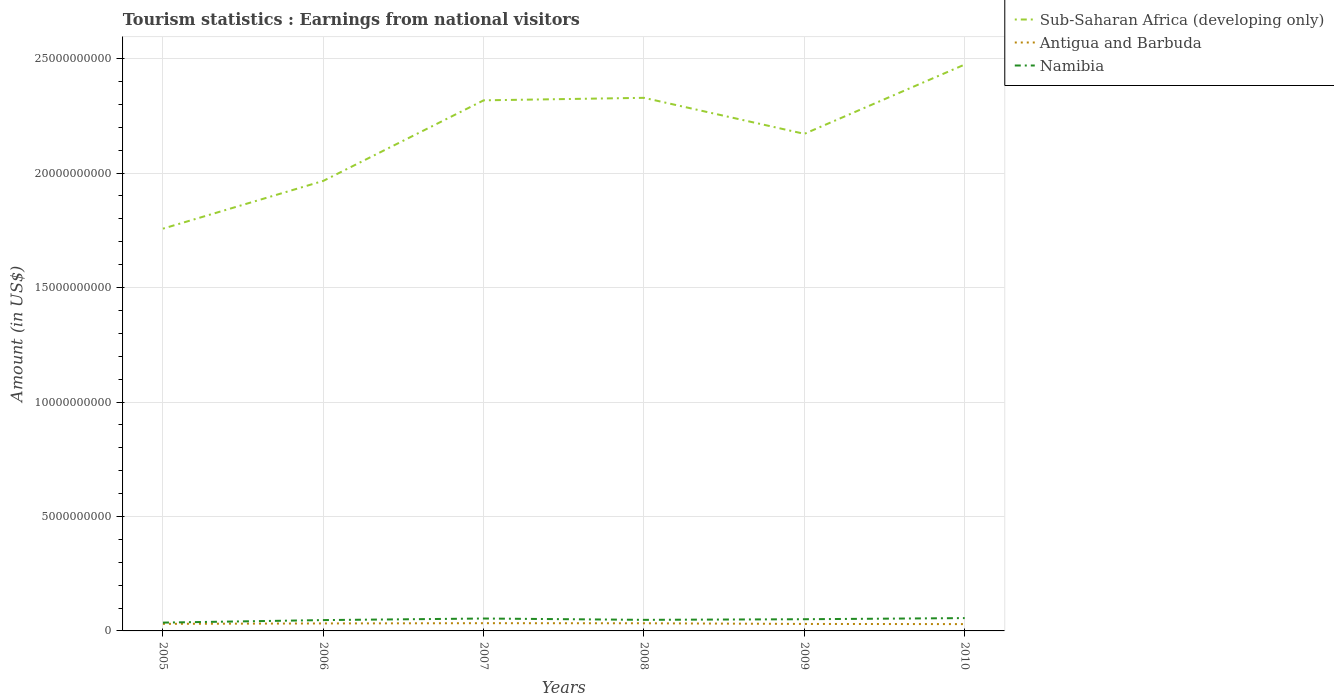Is the number of lines equal to the number of legend labels?
Your response must be concise. Yes. Across all years, what is the maximum earnings from national visitors in Antigua and Barbuda?
Make the answer very short. 2.98e+08. What is the total earnings from national visitors in Namibia in the graph?
Make the answer very short. -1.21e+08. What is the difference between the highest and the second highest earnings from national visitors in Namibia?
Offer a very short reply. 1.97e+08. What is the difference between the highest and the lowest earnings from national visitors in Namibia?
Provide a short and direct response. 3. Is the earnings from national visitors in Antigua and Barbuda strictly greater than the earnings from national visitors in Sub-Saharan Africa (developing only) over the years?
Keep it short and to the point. Yes. How many lines are there?
Your response must be concise. 3. Are the values on the major ticks of Y-axis written in scientific E-notation?
Your answer should be very brief. No. How many legend labels are there?
Make the answer very short. 3. How are the legend labels stacked?
Your answer should be very brief. Vertical. What is the title of the graph?
Provide a succinct answer. Tourism statistics : Earnings from national visitors. What is the Amount (in US$) of Sub-Saharan Africa (developing only) in 2005?
Offer a terse response. 1.76e+1. What is the Amount (in US$) of Antigua and Barbuda in 2005?
Provide a succinct answer. 3.09e+08. What is the Amount (in US$) of Namibia in 2005?
Your response must be concise. 3.63e+08. What is the Amount (in US$) of Sub-Saharan Africa (developing only) in 2006?
Your response must be concise. 1.97e+1. What is the Amount (in US$) of Antigua and Barbuda in 2006?
Your response must be concise. 3.27e+08. What is the Amount (in US$) of Namibia in 2006?
Give a very brief answer. 4.73e+08. What is the Amount (in US$) of Sub-Saharan Africa (developing only) in 2007?
Give a very brief answer. 2.32e+1. What is the Amount (in US$) in Antigua and Barbuda in 2007?
Provide a short and direct response. 3.38e+08. What is the Amount (in US$) of Namibia in 2007?
Make the answer very short. 5.42e+08. What is the Amount (in US$) in Sub-Saharan Africa (developing only) in 2008?
Provide a short and direct response. 2.33e+1. What is the Amount (in US$) of Antigua and Barbuda in 2008?
Provide a succinct answer. 3.34e+08. What is the Amount (in US$) in Namibia in 2008?
Your answer should be compact. 4.84e+08. What is the Amount (in US$) in Sub-Saharan Africa (developing only) in 2009?
Keep it short and to the point. 2.17e+1. What is the Amount (in US$) in Antigua and Barbuda in 2009?
Your answer should be compact. 3.05e+08. What is the Amount (in US$) in Namibia in 2009?
Keep it short and to the point. 5.11e+08. What is the Amount (in US$) of Sub-Saharan Africa (developing only) in 2010?
Offer a terse response. 2.47e+1. What is the Amount (in US$) of Antigua and Barbuda in 2010?
Keep it short and to the point. 2.98e+08. What is the Amount (in US$) in Namibia in 2010?
Offer a very short reply. 5.60e+08. Across all years, what is the maximum Amount (in US$) in Sub-Saharan Africa (developing only)?
Keep it short and to the point. 2.47e+1. Across all years, what is the maximum Amount (in US$) in Antigua and Barbuda?
Your answer should be compact. 3.38e+08. Across all years, what is the maximum Amount (in US$) of Namibia?
Your answer should be very brief. 5.60e+08. Across all years, what is the minimum Amount (in US$) in Sub-Saharan Africa (developing only)?
Your answer should be compact. 1.76e+1. Across all years, what is the minimum Amount (in US$) in Antigua and Barbuda?
Offer a very short reply. 2.98e+08. Across all years, what is the minimum Amount (in US$) in Namibia?
Your answer should be very brief. 3.63e+08. What is the total Amount (in US$) in Sub-Saharan Africa (developing only) in the graph?
Provide a short and direct response. 1.30e+11. What is the total Amount (in US$) of Antigua and Barbuda in the graph?
Make the answer very short. 1.91e+09. What is the total Amount (in US$) in Namibia in the graph?
Give a very brief answer. 2.93e+09. What is the difference between the Amount (in US$) of Sub-Saharan Africa (developing only) in 2005 and that in 2006?
Give a very brief answer. -2.09e+09. What is the difference between the Amount (in US$) in Antigua and Barbuda in 2005 and that in 2006?
Give a very brief answer. -1.80e+07. What is the difference between the Amount (in US$) of Namibia in 2005 and that in 2006?
Keep it short and to the point. -1.10e+08. What is the difference between the Amount (in US$) in Sub-Saharan Africa (developing only) in 2005 and that in 2007?
Make the answer very short. -5.61e+09. What is the difference between the Amount (in US$) of Antigua and Barbuda in 2005 and that in 2007?
Offer a very short reply. -2.90e+07. What is the difference between the Amount (in US$) in Namibia in 2005 and that in 2007?
Keep it short and to the point. -1.79e+08. What is the difference between the Amount (in US$) in Sub-Saharan Africa (developing only) in 2005 and that in 2008?
Offer a terse response. -5.71e+09. What is the difference between the Amount (in US$) in Antigua and Barbuda in 2005 and that in 2008?
Offer a terse response. -2.50e+07. What is the difference between the Amount (in US$) of Namibia in 2005 and that in 2008?
Your response must be concise. -1.21e+08. What is the difference between the Amount (in US$) of Sub-Saharan Africa (developing only) in 2005 and that in 2009?
Make the answer very short. -4.14e+09. What is the difference between the Amount (in US$) in Namibia in 2005 and that in 2009?
Make the answer very short. -1.48e+08. What is the difference between the Amount (in US$) in Sub-Saharan Africa (developing only) in 2005 and that in 2010?
Your answer should be very brief. -7.17e+09. What is the difference between the Amount (in US$) of Antigua and Barbuda in 2005 and that in 2010?
Ensure brevity in your answer.  1.10e+07. What is the difference between the Amount (in US$) in Namibia in 2005 and that in 2010?
Your answer should be very brief. -1.97e+08. What is the difference between the Amount (in US$) in Sub-Saharan Africa (developing only) in 2006 and that in 2007?
Offer a very short reply. -3.52e+09. What is the difference between the Amount (in US$) of Antigua and Barbuda in 2006 and that in 2007?
Your answer should be compact. -1.10e+07. What is the difference between the Amount (in US$) of Namibia in 2006 and that in 2007?
Make the answer very short. -6.90e+07. What is the difference between the Amount (in US$) of Sub-Saharan Africa (developing only) in 2006 and that in 2008?
Provide a succinct answer. -3.63e+09. What is the difference between the Amount (in US$) in Antigua and Barbuda in 2006 and that in 2008?
Offer a terse response. -7.00e+06. What is the difference between the Amount (in US$) in Namibia in 2006 and that in 2008?
Offer a very short reply. -1.10e+07. What is the difference between the Amount (in US$) of Sub-Saharan Africa (developing only) in 2006 and that in 2009?
Make the answer very short. -2.05e+09. What is the difference between the Amount (in US$) in Antigua and Barbuda in 2006 and that in 2009?
Keep it short and to the point. 2.20e+07. What is the difference between the Amount (in US$) of Namibia in 2006 and that in 2009?
Offer a terse response. -3.80e+07. What is the difference between the Amount (in US$) in Sub-Saharan Africa (developing only) in 2006 and that in 2010?
Your answer should be compact. -5.08e+09. What is the difference between the Amount (in US$) of Antigua and Barbuda in 2006 and that in 2010?
Give a very brief answer. 2.90e+07. What is the difference between the Amount (in US$) of Namibia in 2006 and that in 2010?
Provide a short and direct response. -8.70e+07. What is the difference between the Amount (in US$) of Sub-Saharan Africa (developing only) in 2007 and that in 2008?
Your answer should be very brief. -1.09e+08. What is the difference between the Amount (in US$) of Namibia in 2007 and that in 2008?
Provide a short and direct response. 5.80e+07. What is the difference between the Amount (in US$) in Sub-Saharan Africa (developing only) in 2007 and that in 2009?
Offer a very short reply. 1.46e+09. What is the difference between the Amount (in US$) of Antigua and Barbuda in 2007 and that in 2009?
Give a very brief answer. 3.30e+07. What is the difference between the Amount (in US$) in Namibia in 2007 and that in 2009?
Offer a terse response. 3.10e+07. What is the difference between the Amount (in US$) of Sub-Saharan Africa (developing only) in 2007 and that in 2010?
Your answer should be compact. -1.56e+09. What is the difference between the Amount (in US$) of Antigua and Barbuda in 2007 and that in 2010?
Keep it short and to the point. 4.00e+07. What is the difference between the Amount (in US$) in Namibia in 2007 and that in 2010?
Give a very brief answer. -1.80e+07. What is the difference between the Amount (in US$) in Sub-Saharan Africa (developing only) in 2008 and that in 2009?
Ensure brevity in your answer.  1.57e+09. What is the difference between the Amount (in US$) of Antigua and Barbuda in 2008 and that in 2009?
Offer a very short reply. 2.90e+07. What is the difference between the Amount (in US$) in Namibia in 2008 and that in 2009?
Offer a terse response. -2.70e+07. What is the difference between the Amount (in US$) of Sub-Saharan Africa (developing only) in 2008 and that in 2010?
Provide a short and direct response. -1.45e+09. What is the difference between the Amount (in US$) of Antigua and Barbuda in 2008 and that in 2010?
Offer a terse response. 3.60e+07. What is the difference between the Amount (in US$) in Namibia in 2008 and that in 2010?
Your answer should be very brief. -7.60e+07. What is the difference between the Amount (in US$) in Sub-Saharan Africa (developing only) in 2009 and that in 2010?
Offer a terse response. -3.03e+09. What is the difference between the Amount (in US$) in Namibia in 2009 and that in 2010?
Ensure brevity in your answer.  -4.90e+07. What is the difference between the Amount (in US$) in Sub-Saharan Africa (developing only) in 2005 and the Amount (in US$) in Antigua and Barbuda in 2006?
Make the answer very short. 1.72e+1. What is the difference between the Amount (in US$) of Sub-Saharan Africa (developing only) in 2005 and the Amount (in US$) of Namibia in 2006?
Keep it short and to the point. 1.71e+1. What is the difference between the Amount (in US$) of Antigua and Barbuda in 2005 and the Amount (in US$) of Namibia in 2006?
Your answer should be compact. -1.64e+08. What is the difference between the Amount (in US$) of Sub-Saharan Africa (developing only) in 2005 and the Amount (in US$) of Antigua and Barbuda in 2007?
Your response must be concise. 1.72e+1. What is the difference between the Amount (in US$) of Sub-Saharan Africa (developing only) in 2005 and the Amount (in US$) of Namibia in 2007?
Offer a very short reply. 1.70e+1. What is the difference between the Amount (in US$) in Antigua and Barbuda in 2005 and the Amount (in US$) in Namibia in 2007?
Provide a succinct answer. -2.33e+08. What is the difference between the Amount (in US$) of Sub-Saharan Africa (developing only) in 2005 and the Amount (in US$) of Antigua and Barbuda in 2008?
Ensure brevity in your answer.  1.72e+1. What is the difference between the Amount (in US$) in Sub-Saharan Africa (developing only) in 2005 and the Amount (in US$) in Namibia in 2008?
Your answer should be compact. 1.71e+1. What is the difference between the Amount (in US$) in Antigua and Barbuda in 2005 and the Amount (in US$) in Namibia in 2008?
Ensure brevity in your answer.  -1.75e+08. What is the difference between the Amount (in US$) in Sub-Saharan Africa (developing only) in 2005 and the Amount (in US$) in Antigua and Barbuda in 2009?
Your answer should be very brief. 1.73e+1. What is the difference between the Amount (in US$) in Sub-Saharan Africa (developing only) in 2005 and the Amount (in US$) in Namibia in 2009?
Your answer should be very brief. 1.71e+1. What is the difference between the Amount (in US$) of Antigua and Barbuda in 2005 and the Amount (in US$) of Namibia in 2009?
Provide a short and direct response. -2.02e+08. What is the difference between the Amount (in US$) in Sub-Saharan Africa (developing only) in 2005 and the Amount (in US$) in Antigua and Barbuda in 2010?
Provide a short and direct response. 1.73e+1. What is the difference between the Amount (in US$) in Sub-Saharan Africa (developing only) in 2005 and the Amount (in US$) in Namibia in 2010?
Offer a terse response. 1.70e+1. What is the difference between the Amount (in US$) of Antigua and Barbuda in 2005 and the Amount (in US$) of Namibia in 2010?
Give a very brief answer. -2.51e+08. What is the difference between the Amount (in US$) in Sub-Saharan Africa (developing only) in 2006 and the Amount (in US$) in Antigua and Barbuda in 2007?
Ensure brevity in your answer.  1.93e+1. What is the difference between the Amount (in US$) in Sub-Saharan Africa (developing only) in 2006 and the Amount (in US$) in Namibia in 2007?
Your answer should be very brief. 1.91e+1. What is the difference between the Amount (in US$) in Antigua and Barbuda in 2006 and the Amount (in US$) in Namibia in 2007?
Make the answer very short. -2.15e+08. What is the difference between the Amount (in US$) of Sub-Saharan Africa (developing only) in 2006 and the Amount (in US$) of Antigua and Barbuda in 2008?
Keep it short and to the point. 1.93e+1. What is the difference between the Amount (in US$) of Sub-Saharan Africa (developing only) in 2006 and the Amount (in US$) of Namibia in 2008?
Offer a terse response. 1.92e+1. What is the difference between the Amount (in US$) of Antigua and Barbuda in 2006 and the Amount (in US$) of Namibia in 2008?
Give a very brief answer. -1.57e+08. What is the difference between the Amount (in US$) of Sub-Saharan Africa (developing only) in 2006 and the Amount (in US$) of Antigua and Barbuda in 2009?
Provide a short and direct response. 1.94e+1. What is the difference between the Amount (in US$) of Sub-Saharan Africa (developing only) in 2006 and the Amount (in US$) of Namibia in 2009?
Keep it short and to the point. 1.91e+1. What is the difference between the Amount (in US$) of Antigua and Barbuda in 2006 and the Amount (in US$) of Namibia in 2009?
Give a very brief answer. -1.84e+08. What is the difference between the Amount (in US$) of Sub-Saharan Africa (developing only) in 2006 and the Amount (in US$) of Antigua and Barbuda in 2010?
Your response must be concise. 1.94e+1. What is the difference between the Amount (in US$) in Sub-Saharan Africa (developing only) in 2006 and the Amount (in US$) in Namibia in 2010?
Ensure brevity in your answer.  1.91e+1. What is the difference between the Amount (in US$) of Antigua and Barbuda in 2006 and the Amount (in US$) of Namibia in 2010?
Provide a succinct answer. -2.33e+08. What is the difference between the Amount (in US$) in Sub-Saharan Africa (developing only) in 2007 and the Amount (in US$) in Antigua and Barbuda in 2008?
Ensure brevity in your answer.  2.28e+1. What is the difference between the Amount (in US$) in Sub-Saharan Africa (developing only) in 2007 and the Amount (in US$) in Namibia in 2008?
Give a very brief answer. 2.27e+1. What is the difference between the Amount (in US$) of Antigua and Barbuda in 2007 and the Amount (in US$) of Namibia in 2008?
Provide a succinct answer. -1.46e+08. What is the difference between the Amount (in US$) of Sub-Saharan Africa (developing only) in 2007 and the Amount (in US$) of Antigua and Barbuda in 2009?
Offer a terse response. 2.29e+1. What is the difference between the Amount (in US$) of Sub-Saharan Africa (developing only) in 2007 and the Amount (in US$) of Namibia in 2009?
Ensure brevity in your answer.  2.27e+1. What is the difference between the Amount (in US$) in Antigua and Barbuda in 2007 and the Amount (in US$) in Namibia in 2009?
Your response must be concise. -1.73e+08. What is the difference between the Amount (in US$) of Sub-Saharan Africa (developing only) in 2007 and the Amount (in US$) of Antigua and Barbuda in 2010?
Provide a short and direct response. 2.29e+1. What is the difference between the Amount (in US$) in Sub-Saharan Africa (developing only) in 2007 and the Amount (in US$) in Namibia in 2010?
Give a very brief answer. 2.26e+1. What is the difference between the Amount (in US$) of Antigua and Barbuda in 2007 and the Amount (in US$) of Namibia in 2010?
Keep it short and to the point. -2.22e+08. What is the difference between the Amount (in US$) in Sub-Saharan Africa (developing only) in 2008 and the Amount (in US$) in Antigua and Barbuda in 2009?
Offer a very short reply. 2.30e+1. What is the difference between the Amount (in US$) of Sub-Saharan Africa (developing only) in 2008 and the Amount (in US$) of Namibia in 2009?
Keep it short and to the point. 2.28e+1. What is the difference between the Amount (in US$) in Antigua and Barbuda in 2008 and the Amount (in US$) in Namibia in 2009?
Keep it short and to the point. -1.77e+08. What is the difference between the Amount (in US$) of Sub-Saharan Africa (developing only) in 2008 and the Amount (in US$) of Antigua and Barbuda in 2010?
Your answer should be very brief. 2.30e+1. What is the difference between the Amount (in US$) in Sub-Saharan Africa (developing only) in 2008 and the Amount (in US$) in Namibia in 2010?
Your answer should be compact. 2.27e+1. What is the difference between the Amount (in US$) in Antigua and Barbuda in 2008 and the Amount (in US$) in Namibia in 2010?
Offer a very short reply. -2.26e+08. What is the difference between the Amount (in US$) of Sub-Saharan Africa (developing only) in 2009 and the Amount (in US$) of Antigua and Barbuda in 2010?
Offer a very short reply. 2.14e+1. What is the difference between the Amount (in US$) in Sub-Saharan Africa (developing only) in 2009 and the Amount (in US$) in Namibia in 2010?
Your answer should be very brief. 2.12e+1. What is the difference between the Amount (in US$) of Antigua and Barbuda in 2009 and the Amount (in US$) of Namibia in 2010?
Give a very brief answer. -2.55e+08. What is the average Amount (in US$) of Sub-Saharan Africa (developing only) per year?
Your answer should be very brief. 2.17e+1. What is the average Amount (in US$) of Antigua and Barbuda per year?
Your answer should be very brief. 3.18e+08. What is the average Amount (in US$) of Namibia per year?
Keep it short and to the point. 4.89e+08. In the year 2005, what is the difference between the Amount (in US$) in Sub-Saharan Africa (developing only) and Amount (in US$) in Antigua and Barbuda?
Provide a short and direct response. 1.73e+1. In the year 2005, what is the difference between the Amount (in US$) in Sub-Saharan Africa (developing only) and Amount (in US$) in Namibia?
Your answer should be very brief. 1.72e+1. In the year 2005, what is the difference between the Amount (in US$) in Antigua and Barbuda and Amount (in US$) in Namibia?
Keep it short and to the point. -5.40e+07. In the year 2006, what is the difference between the Amount (in US$) of Sub-Saharan Africa (developing only) and Amount (in US$) of Antigua and Barbuda?
Give a very brief answer. 1.93e+1. In the year 2006, what is the difference between the Amount (in US$) of Sub-Saharan Africa (developing only) and Amount (in US$) of Namibia?
Keep it short and to the point. 1.92e+1. In the year 2006, what is the difference between the Amount (in US$) in Antigua and Barbuda and Amount (in US$) in Namibia?
Your answer should be very brief. -1.46e+08. In the year 2007, what is the difference between the Amount (in US$) in Sub-Saharan Africa (developing only) and Amount (in US$) in Antigua and Barbuda?
Make the answer very short. 2.28e+1. In the year 2007, what is the difference between the Amount (in US$) of Sub-Saharan Africa (developing only) and Amount (in US$) of Namibia?
Keep it short and to the point. 2.26e+1. In the year 2007, what is the difference between the Amount (in US$) of Antigua and Barbuda and Amount (in US$) of Namibia?
Keep it short and to the point. -2.04e+08. In the year 2008, what is the difference between the Amount (in US$) of Sub-Saharan Africa (developing only) and Amount (in US$) of Antigua and Barbuda?
Give a very brief answer. 2.30e+1. In the year 2008, what is the difference between the Amount (in US$) in Sub-Saharan Africa (developing only) and Amount (in US$) in Namibia?
Offer a very short reply. 2.28e+1. In the year 2008, what is the difference between the Amount (in US$) of Antigua and Barbuda and Amount (in US$) of Namibia?
Your response must be concise. -1.50e+08. In the year 2009, what is the difference between the Amount (in US$) of Sub-Saharan Africa (developing only) and Amount (in US$) of Antigua and Barbuda?
Provide a short and direct response. 2.14e+1. In the year 2009, what is the difference between the Amount (in US$) in Sub-Saharan Africa (developing only) and Amount (in US$) in Namibia?
Your response must be concise. 2.12e+1. In the year 2009, what is the difference between the Amount (in US$) of Antigua and Barbuda and Amount (in US$) of Namibia?
Your response must be concise. -2.06e+08. In the year 2010, what is the difference between the Amount (in US$) in Sub-Saharan Africa (developing only) and Amount (in US$) in Antigua and Barbuda?
Offer a very short reply. 2.44e+1. In the year 2010, what is the difference between the Amount (in US$) of Sub-Saharan Africa (developing only) and Amount (in US$) of Namibia?
Ensure brevity in your answer.  2.42e+1. In the year 2010, what is the difference between the Amount (in US$) of Antigua and Barbuda and Amount (in US$) of Namibia?
Ensure brevity in your answer.  -2.62e+08. What is the ratio of the Amount (in US$) in Sub-Saharan Africa (developing only) in 2005 to that in 2006?
Provide a short and direct response. 0.89. What is the ratio of the Amount (in US$) of Antigua and Barbuda in 2005 to that in 2006?
Ensure brevity in your answer.  0.94. What is the ratio of the Amount (in US$) of Namibia in 2005 to that in 2006?
Your response must be concise. 0.77. What is the ratio of the Amount (in US$) of Sub-Saharan Africa (developing only) in 2005 to that in 2007?
Provide a succinct answer. 0.76. What is the ratio of the Amount (in US$) of Antigua and Barbuda in 2005 to that in 2007?
Your response must be concise. 0.91. What is the ratio of the Amount (in US$) in Namibia in 2005 to that in 2007?
Make the answer very short. 0.67. What is the ratio of the Amount (in US$) in Sub-Saharan Africa (developing only) in 2005 to that in 2008?
Offer a very short reply. 0.75. What is the ratio of the Amount (in US$) of Antigua and Barbuda in 2005 to that in 2008?
Make the answer very short. 0.93. What is the ratio of the Amount (in US$) in Sub-Saharan Africa (developing only) in 2005 to that in 2009?
Keep it short and to the point. 0.81. What is the ratio of the Amount (in US$) of Antigua and Barbuda in 2005 to that in 2009?
Your answer should be very brief. 1.01. What is the ratio of the Amount (in US$) in Namibia in 2005 to that in 2009?
Give a very brief answer. 0.71. What is the ratio of the Amount (in US$) in Sub-Saharan Africa (developing only) in 2005 to that in 2010?
Keep it short and to the point. 0.71. What is the ratio of the Amount (in US$) of Antigua and Barbuda in 2005 to that in 2010?
Ensure brevity in your answer.  1.04. What is the ratio of the Amount (in US$) of Namibia in 2005 to that in 2010?
Offer a terse response. 0.65. What is the ratio of the Amount (in US$) in Sub-Saharan Africa (developing only) in 2006 to that in 2007?
Your answer should be very brief. 0.85. What is the ratio of the Amount (in US$) of Antigua and Barbuda in 2006 to that in 2007?
Your answer should be very brief. 0.97. What is the ratio of the Amount (in US$) of Namibia in 2006 to that in 2007?
Offer a very short reply. 0.87. What is the ratio of the Amount (in US$) in Sub-Saharan Africa (developing only) in 2006 to that in 2008?
Keep it short and to the point. 0.84. What is the ratio of the Amount (in US$) in Namibia in 2006 to that in 2008?
Offer a very short reply. 0.98. What is the ratio of the Amount (in US$) of Sub-Saharan Africa (developing only) in 2006 to that in 2009?
Offer a terse response. 0.91. What is the ratio of the Amount (in US$) in Antigua and Barbuda in 2006 to that in 2009?
Provide a succinct answer. 1.07. What is the ratio of the Amount (in US$) of Namibia in 2006 to that in 2009?
Ensure brevity in your answer.  0.93. What is the ratio of the Amount (in US$) in Sub-Saharan Africa (developing only) in 2006 to that in 2010?
Your response must be concise. 0.79. What is the ratio of the Amount (in US$) in Antigua and Barbuda in 2006 to that in 2010?
Provide a succinct answer. 1.1. What is the ratio of the Amount (in US$) of Namibia in 2006 to that in 2010?
Give a very brief answer. 0.84. What is the ratio of the Amount (in US$) of Sub-Saharan Africa (developing only) in 2007 to that in 2008?
Ensure brevity in your answer.  1. What is the ratio of the Amount (in US$) in Antigua and Barbuda in 2007 to that in 2008?
Offer a terse response. 1.01. What is the ratio of the Amount (in US$) of Namibia in 2007 to that in 2008?
Offer a terse response. 1.12. What is the ratio of the Amount (in US$) in Sub-Saharan Africa (developing only) in 2007 to that in 2009?
Offer a very short reply. 1.07. What is the ratio of the Amount (in US$) in Antigua and Barbuda in 2007 to that in 2009?
Offer a very short reply. 1.11. What is the ratio of the Amount (in US$) in Namibia in 2007 to that in 2009?
Provide a succinct answer. 1.06. What is the ratio of the Amount (in US$) of Sub-Saharan Africa (developing only) in 2007 to that in 2010?
Give a very brief answer. 0.94. What is the ratio of the Amount (in US$) in Antigua and Barbuda in 2007 to that in 2010?
Your answer should be very brief. 1.13. What is the ratio of the Amount (in US$) of Namibia in 2007 to that in 2010?
Your answer should be compact. 0.97. What is the ratio of the Amount (in US$) in Sub-Saharan Africa (developing only) in 2008 to that in 2009?
Offer a very short reply. 1.07. What is the ratio of the Amount (in US$) in Antigua and Barbuda in 2008 to that in 2009?
Your answer should be very brief. 1.1. What is the ratio of the Amount (in US$) in Namibia in 2008 to that in 2009?
Ensure brevity in your answer.  0.95. What is the ratio of the Amount (in US$) in Antigua and Barbuda in 2008 to that in 2010?
Ensure brevity in your answer.  1.12. What is the ratio of the Amount (in US$) of Namibia in 2008 to that in 2010?
Make the answer very short. 0.86. What is the ratio of the Amount (in US$) of Sub-Saharan Africa (developing only) in 2009 to that in 2010?
Give a very brief answer. 0.88. What is the ratio of the Amount (in US$) in Antigua and Barbuda in 2009 to that in 2010?
Your answer should be compact. 1.02. What is the ratio of the Amount (in US$) in Namibia in 2009 to that in 2010?
Provide a short and direct response. 0.91. What is the difference between the highest and the second highest Amount (in US$) of Sub-Saharan Africa (developing only)?
Keep it short and to the point. 1.45e+09. What is the difference between the highest and the second highest Amount (in US$) of Antigua and Barbuda?
Your answer should be very brief. 4.00e+06. What is the difference between the highest and the second highest Amount (in US$) of Namibia?
Your answer should be very brief. 1.80e+07. What is the difference between the highest and the lowest Amount (in US$) of Sub-Saharan Africa (developing only)?
Provide a succinct answer. 7.17e+09. What is the difference between the highest and the lowest Amount (in US$) of Antigua and Barbuda?
Provide a short and direct response. 4.00e+07. What is the difference between the highest and the lowest Amount (in US$) in Namibia?
Give a very brief answer. 1.97e+08. 